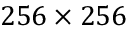<formula> <loc_0><loc_0><loc_500><loc_500>2 5 6 \times 2 5 6</formula> 